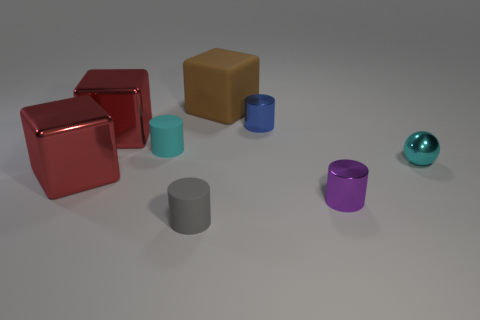Add 1 tiny cyan cylinders. How many objects exist? 9 Subtract all balls. How many objects are left? 7 Subtract all small cyan cylinders. Subtract all balls. How many objects are left? 6 Add 8 small blue cylinders. How many small blue cylinders are left? 9 Add 2 brown matte objects. How many brown matte objects exist? 3 Subtract 0 cyan cubes. How many objects are left? 8 